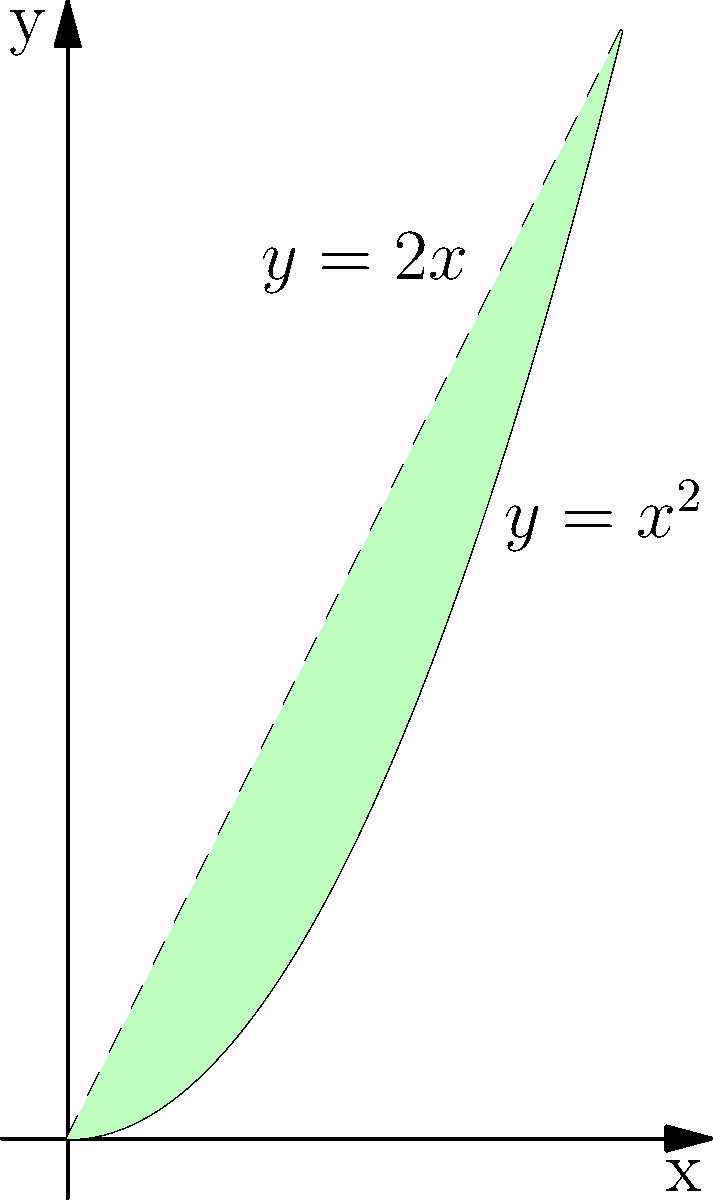Calculate the area between the curves $y=x^2$ and $y=2x$ from $x=0$ to $x=2$. Round your answer to two decimal places if necessary. To find the area between two curves, we need to:

1) Determine which function is on top: 
   $2x > x^2$ when $0 < x < 2$, so $y=2x$ is the upper function.

2) Set up the integral:
   Area = $\int_0^2 (2x - x^2) dx$

3) Solve the integral:
   $\int_0^2 (2x - x^2) dx = [x^2 - \frac{1}{3}x^3]_0^2$

4) Evaluate the antiderivative:
   $= (2^2 - \frac{1}{3}2^3) - (0^2 - \frac{1}{3}0^3)$
   $= (4 - \frac{8}{3}) - 0$
   $= \frac{12}{3} - \frac{8}{3}$
   $= \frac{4}{3}$

5) Convert to decimal:
   $\frac{4}{3} \approx 1.33$

Therefore, the area between the curves is approximately 1.33 square units.
Answer: $\frac{4}{3}$ or 1.33 square units 